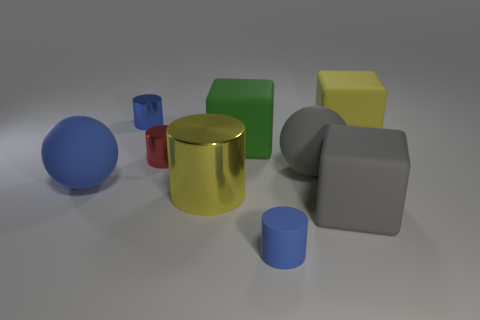How many yellow things are the same size as the gray rubber ball?
Offer a terse response. 2. Are there fewer big objects that are in front of the big yellow matte thing than tiny red cylinders?
Your answer should be compact. No. There is a gray matte sphere; how many tiny blue rubber objects are to the left of it?
Provide a succinct answer. 1. There is a matte object that is left of the small cylinder that is left of the red object in front of the yellow block; what size is it?
Provide a succinct answer. Large. There is a large blue object; does it have the same shape as the big yellow object in front of the large yellow matte block?
Offer a very short reply. No. What is the size of the red cylinder that is the same material as the big yellow cylinder?
Your answer should be compact. Small. Is there anything else of the same color as the big shiny cylinder?
Provide a short and direct response. Yes. The sphere that is left of the shiny thing behind the small red object behind the yellow metal cylinder is made of what material?
Offer a very short reply. Rubber. How many rubber things are either purple cylinders or big balls?
Provide a short and direct response. 2. Is the small rubber cylinder the same color as the large metal thing?
Your response must be concise. No. 